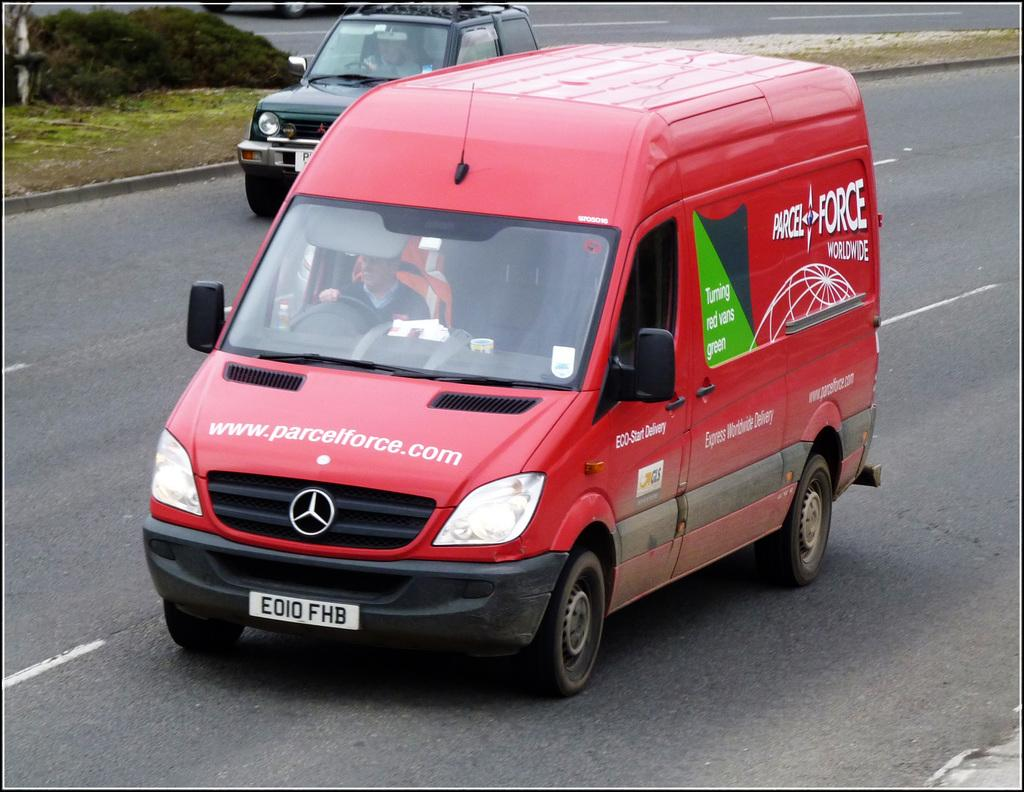<image>
Share a concise interpretation of the image provided. A box fan with the company Parcel Force on the side 